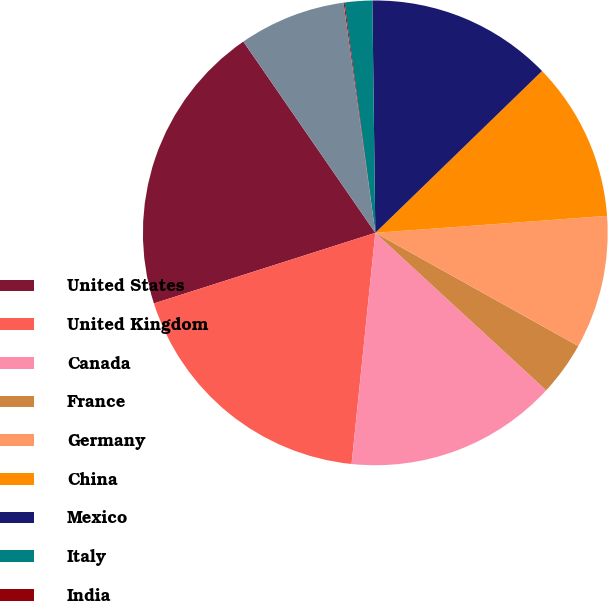<chart> <loc_0><loc_0><loc_500><loc_500><pie_chart><fcel>United States<fcel>United Kingdom<fcel>Canada<fcel>France<fcel>Germany<fcel>China<fcel>Mexico<fcel>Italy<fcel>India<fcel>Australia<nl><fcel>20.3%<fcel>18.46%<fcel>14.78%<fcel>3.75%<fcel>9.26%<fcel>11.1%<fcel>12.94%<fcel>1.91%<fcel>0.07%<fcel>7.43%<nl></chart> 